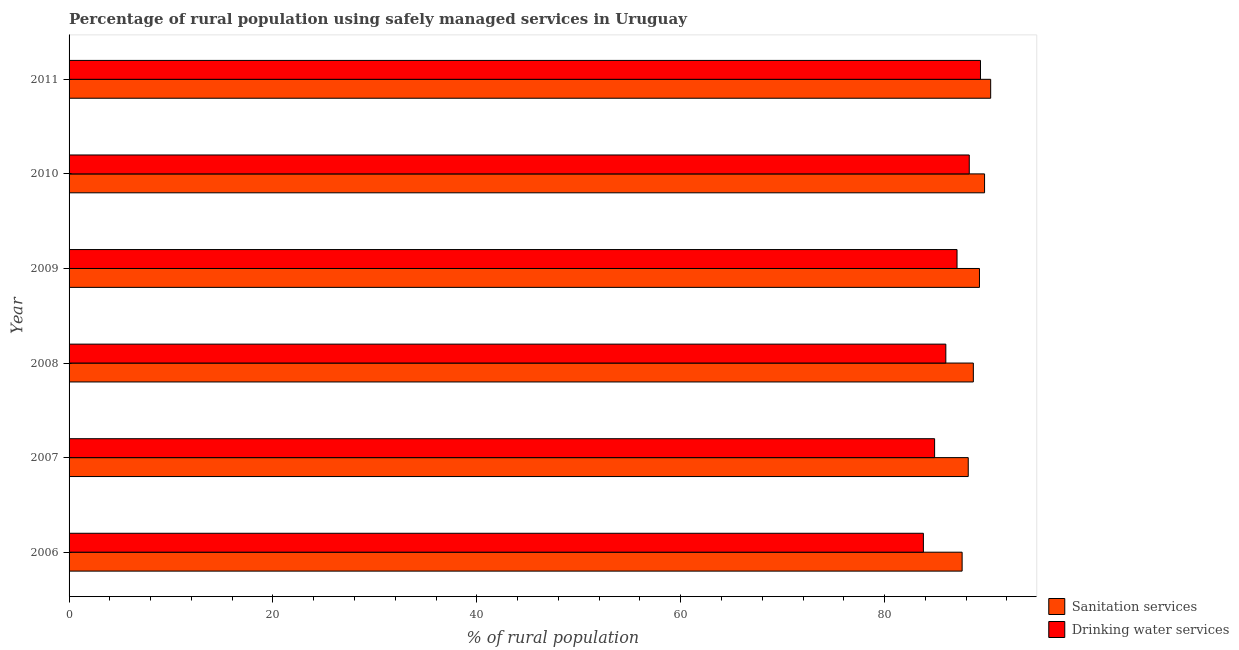How many different coloured bars are there?
Keep it short and to the point. 2. Are the number of bars on each tick of the Y-axis equal?
Offer a terse response. Yes. How many bars are there on the 1st tick from the bottom?
Provide a succinct answer. 2. In how many cases, is the number of bars for a given year not equal to the number of legend labels?
Provide a succinct answer. 0. What is the percentage of rural population who used sanitation services in 2011?
Your answer should be compact. 90.4. Across all years, what is the maximum percentage of rural population who used sanitation services?
Make the answer very short. 90.4. Across all years, what is the minimum percentage of rural population who used drinking water services?
Your response must be concise. 83.8. In which year was the percentage of rural population who used drinking water services maximum?
Provide a short and direct response. 2011. In which year was the percentage of rural population who used drinking water services minimum?
Make the answer very short. 2006. What is the total percentage of rural population who used sanitation services in the graph?
Your response must be concise. 534. What is the difference between the percentage of rural population who used drinking water services in 2009 and the percentage of rural population who used sanitation services in 2010?
Ensure brevity in your answer.  -2.7. What is the average percentage of rural population who used drinking water services per year?
Keep it short and to the point. 86.58. In the year 2009, what is the difference between the percentage of rural population who used drinking water services and percentage of rural population who used sanitation services?
Offer a very short reply. -2.2. In how many years, is the percentage of rural population who used sanitation services greater than 88 %?
Your answer should be compact. 5. Is the difference between the percentage of rural population who used sanitation services in 2008 and 2010 greater than the difference between the percentage of rural population who used drinking water services in 2008 and 2010?
Your answer should be very brief. Yes. What is the difference between the highest and the lowest percentage of rural population who used sanitation services?
Make the answer very short. 2.8. What does the 1st bar from the top in 2006 represents?
Your answer should be very brief. Drinking water services. What does the 2nd bar from the bottom in 2006 represents?
Your answer should be compact. Drinking water services. Are all the bars in the graph horizontal?
Make the answer very short. Yes. What is the difference between two consecutive major ticks on the X-axis?
Ensure brevity in your answer.  20. Does the graph contain any zero values?
Your answer should be very brief. No. Does the graph contain grids?
Offer a very short reply. No. Where does the legend appear in the graph?
Provide a short and direct response. Bottom right. How many legend labels are there?
Provide a short and direct response. 2. How are the legend labels stacked?
Your response must be concise. Vertical. What is the title of the graph?
Ensure brevity in your answer.  Percentage of rural population using safely managed services in Uruguay. What is the label or title of the X-axis?
Ensure brevity in your answer.  % of rural population. What is the label or title of the Y-axis?
Provide a succinct answer. Year. What is the % of rural population of Sanitation services in 2006?
Make the answer very short. 87.6. What is the % of rural population of Drinking water services in 2006?
Your answer should be compact. 83.8. What is the % of rural population of Sanitation services in 2007?
Keep it short and to the point. 88.2. What is the % of rural population of Drinking water services in 2007?
Give a very brief answer. 84.9. What is the % of rural population in Sanitation services in 2008?
Provide a short and direct response. 88.7. What is the % of rural population of Sanitation services in 2009?
Your response must be concise. 89.3. What is the % of rural population in Drinking water services in 2009?
Your answer should be very brief. 87.1. What is the % of rural population of Sanitation services in 2010?
Make the answer very short. 89.8. What is the % of rural population in Drinking water services in 2010?
Keep it short and to the point. 88.3. What is the % of rural population in Sanitation services in 2011?
Your answer should be compact. 90.4. What is the % of rural population in Drinking water services in 2011?
Keep it short and to the point. 89.4. Across all years, what is the maximum % of rural population in Sanitation services?
Make the answer very short. 90.4. Across all years, what is the maximum % of rural population in Drinking water services?
Your answer should be very brief. 89.4. Across all years, what is the minimum % of rural population of Sanitation services?
Your response must be concise. 87.6. Across all years, what is the minimum % of rural population of Drinking water services?
Your answer should be compact. 83.8. What is the total % of rural population in Sanitation services in the graph?
Keep it short and to the point. 534. What is the total % of rural population of Drinking water services in the graph?
Provide a short and direct response. 519.5. What is the difference between the % of rural population of Sanitation services in 2006 and that in 2007?
Your answer should be compact. -0.6. What is the difference between the % of rural population of Drinking water services in 2006 and that in 2007?
Give a very brief answer. -1.1. What is the difference between the % of rural population in Sanitation services in 2006 and that in 2009?
Offer a very short reply. -1.7. What is the difference between the % of rural population of Drinking water services in 2006 and that in 2009?
Provide a short and direct response. -3.3. What is the difference between the % of rural population in Sanitation services in 2006 and that in 2011?
Provide a succinct answer. -2.8. What is the difference between the % of rural population in Drinking water services in 2006 and that in 2011?
Provide a short and direct response. -5.6. What is the difference between the % of rural population of Sanitation services in 2007 and that in 2008?
Offer a terse response. -0.5. What is the difference between the % of rural population in Drinking water services in 2007 and that in 2008?
Provide a succinct answer. -1.1. What is the difference between the % of rural population of Sanitation services in 2007 and that in 2009?
Provide a short and direct response. -1.1. What is the difference between the % of rural population in Sanitation services in 2007 and that in 2011?
Keep it short and to the point. -2.2. What is the difference between the % of rural population of Drinking water services in 2007 and that in 2011?
Make the answer very short. -4.5. What is the difference between the % of rural population in Sanitation services in 2008 and that in 2009?
Give a very brief answer. -0.6. What is the difference between the % of rural population in Sanitation services in 2008 and that in 2010?
Your answer should be very brief. -1.1. What is the difference between the % of rural population in Drinking water services in 2008 and that in 2011?
Your answer should be compact. -3.4. What is the difference between the % of rural population in Sanitation services in 2009 and that in 2010?
Offer a very short reply. -0.5. What is the difference between the % of rural population in Drinking water services in 2009 and that in 2010?
Ensure brevity in your answer.  -1.2. What is the difference between the % of rural population of Drinking water services in 2009 and that in 2011?
Your answer should be very brief. -2.3. What is the difference between the % of rural population in Drinking water services in 2010 and that in 2011?
Your answer should be very brief. -1.1. What is the difference between the % of rural population in Sanitation services in 2006 and the % of rural population in Drinking water services in 2007?
Your response must be concise. 2.7. What is the difference between the % of rural population of Sanitation services in 2006 and the % of rural population of Drinking water services in 2008?
Your answer should be compact. 1.6. What is the difference between the % of rural population of Sanitation services in 2006 and the % of rural population of Drinking water services in 2009?
Your answer should be very brief. 0.5. What is the difference between the % of rural population in Sanitation services in 2007 and the % of rural population in Drinking water services in 2008?
Your answer should be compact. 2.2. What is the difference between the % of rural population in Sanitation services in 2008 and the % of rural population in Drinking water services in 2009?
Your answer should be compact. 1.6. What is the difference between the % of rural population in Sanitation services in 2008 and the % of rural population in Drinking water services in 2010?
Your answer should be compact. 0.4. What is the difference between the % of rural population in Sanitation services in 2008 and the % of rural population in Drinking water services in 2011?
Make the answer very short. -0.7. What is the difference between the % of rural population of Sanitation services in 2009 and the % of rural population of Drinking water services in 2010?
Give a very brief answer. 1. What is the average % of rural population of Sanitation services per year?
Keep it short and to the point. 89. What is the average % of rural population of Drinking water services per year?
Offer a terse response. 86.58. In the year 2006, what is the difference between the % of rural population in Sanitation services and % of rural population in Drinking water services?
Keep it short and to the point. 3.8. In the year 2008, what is the difference between the % of rural population of Sanitation services and % of rural population of Drinking water services?
Offer a very short reply. 2.7. In the year 2011, what is the difference between the % of rural population in Sanitation services and % of rural population in Drinking water services?
Offer a terse response. 1. What is the ratio of the % of rural population in Sanitation services in 2006 to that in 2008?
Offer a very short reply. 0.99. What is the ratio of the % of rural population in Drinking water services in 2006 to that in 2008?
Offer a very short reply. 0.97. What is the ratio of the % of rural population of Sanitation services in 2006 to that in 2009?
Offer a terse response. 0.98. What is the ratio of the % of rural population in Drinking water services in 2006 to that in 2009?
Offer a terse response. 0.96. What is the ratio of the % of rural population of Sanitation services in 2006 to that in 2010?
Ensure brevity in your answer.  0.98. What is the ratio of the % of rural population of Drinking water services in 2006 to that in 2010?
Provide a succinct answer. 0.95. What is the ratio of the % of rural population in Sanitation services in 2006 to that in 2011?
Ensure brevity in your answer.  0.97. What is the ratio of the % of rural population of Drinking water services in 2006 to that in 2011?
Keep it short and to the point. 0.94. What is the ratio of the % of rural population of Sanitation services in 2007 to that in 2008?
Keep it short and to the point. 0.99. What is the ratio of the % of rural population in Drinking water services in 2007 to that in 2008?
Make the answer very short. 0.99. What is the ratio of the % of rural population of Sanitation services in 2007 to that in 2009?
Give a very brief answer. 0.99. What is the ratio of the % of rural population in Drinking water services in 2007 to that in 2009?
Give a very brief answer. 0.97. What is the ratio of the % of rural population of Sanitation services in 2007 to that in 2010?
Give a very brief answer. 0.98. What is the ratio of the % of rural population in Drinking water services in 2007 to that in 2010?
Keep it short and to the point. 0.96. What is the ratio of the % of rural population in Sanitation services in 2007 to that in 2011?
Your answer should be compact. 0.98. What is the ratio of the % of rural population in Drinking water services in 2007 to that in 2011?
Your response must be concise. 0.95. What is the ratio of the % of rural population of Sanitation services in 2008 to that in 2009?
Ensure brevity in your answer.  0.99. What is the ratio of the % of rural population of Drinking water services in 2008 to that in 2009?
Provide a succinct answer. 0.99. What is the ratio of the % of rural population in Sanitation services in 2008 to that in 2011?
Ensure brevity in your answer.  0.98. What is the ratio of the % of rural population in Drinking water services in 2008 to that in 2011?
Offer a terse response. 0.96. What is the ratio of the % of rural population in Drinking water services in 2009 to that in 2010?
Ensure brevity in your answer.  0.99. What is the ratio of the % of rural population of Drinking water services in 2009 to that in 2011?
Offer a very short reply. 0.97. What is the ratio of the % of rural population of Sanitation services in 2010 to that in 2011?
Ensure brevity in your answer.  0.99. What is the difference between the highest and the lowest % of rural population of Sanitation services?
Offer a terse response. 2.8. 